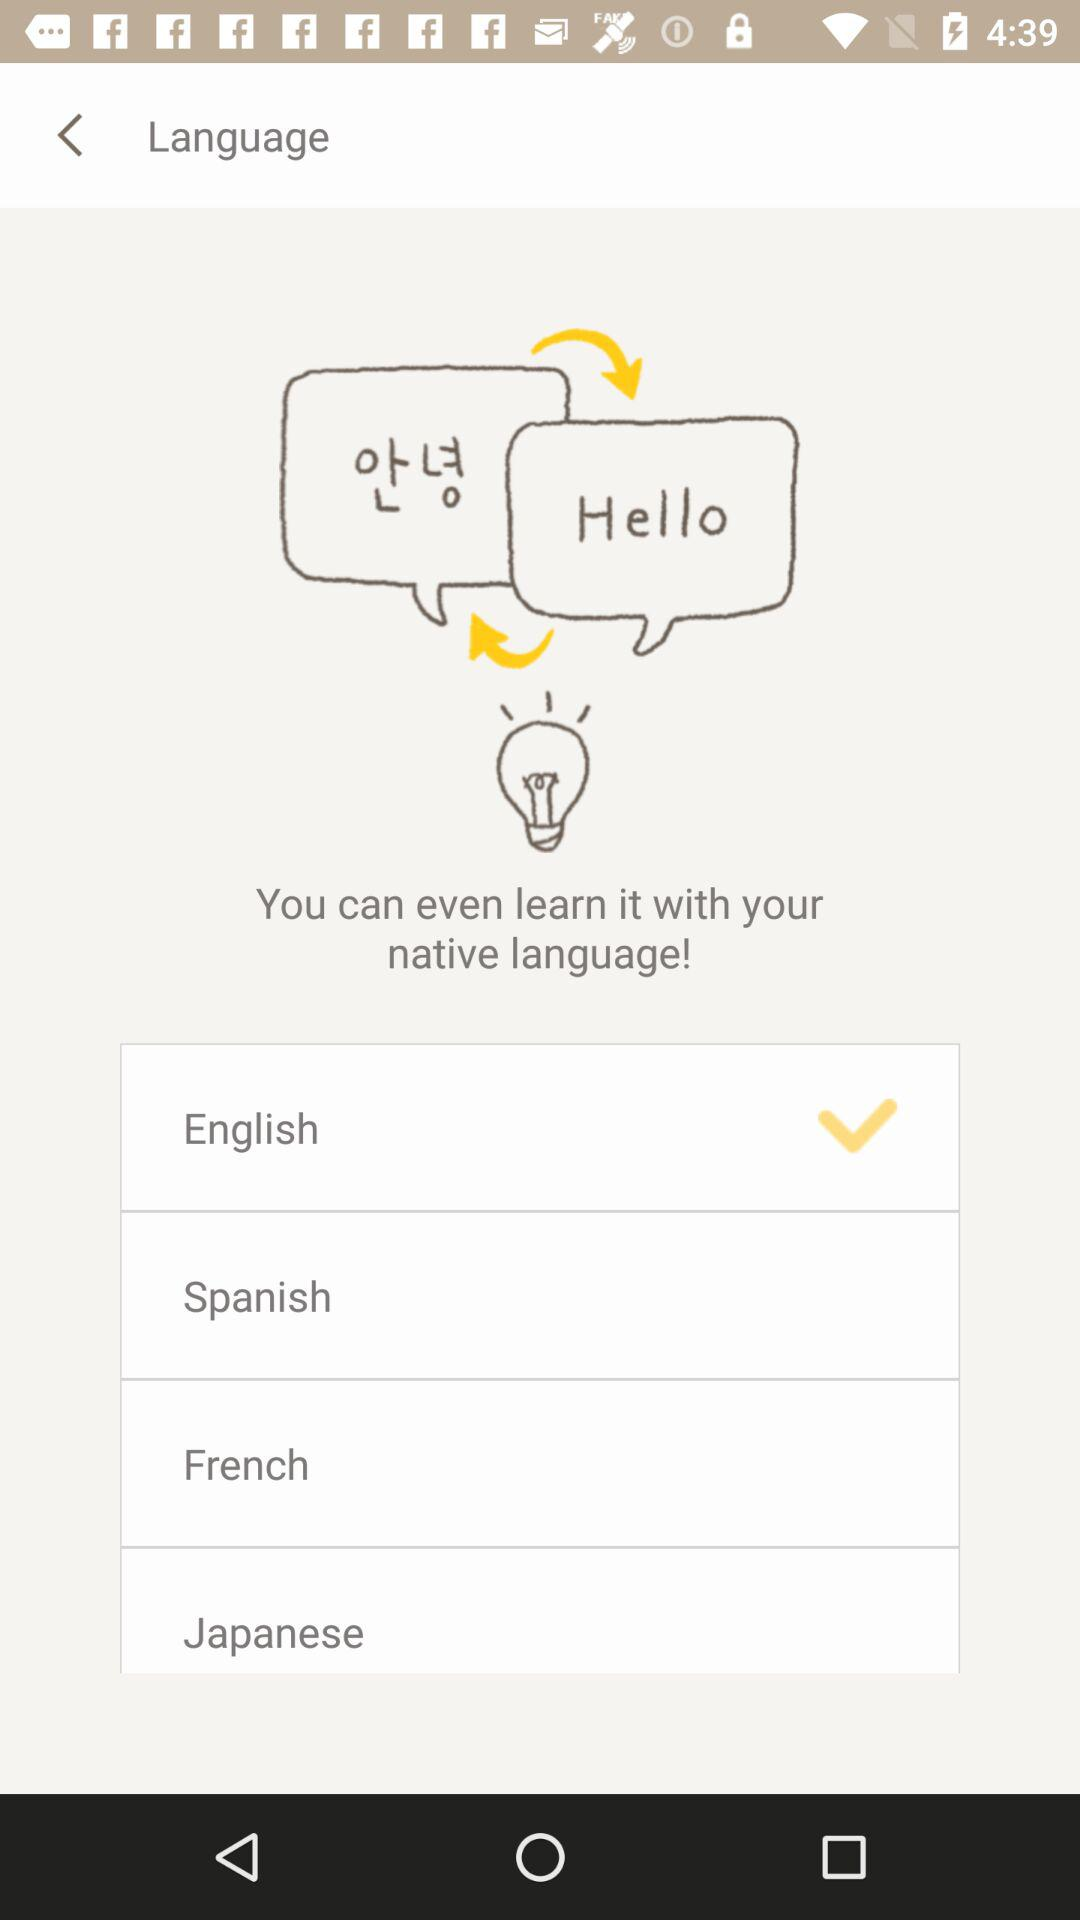Which language is selected? The selected language is English. 